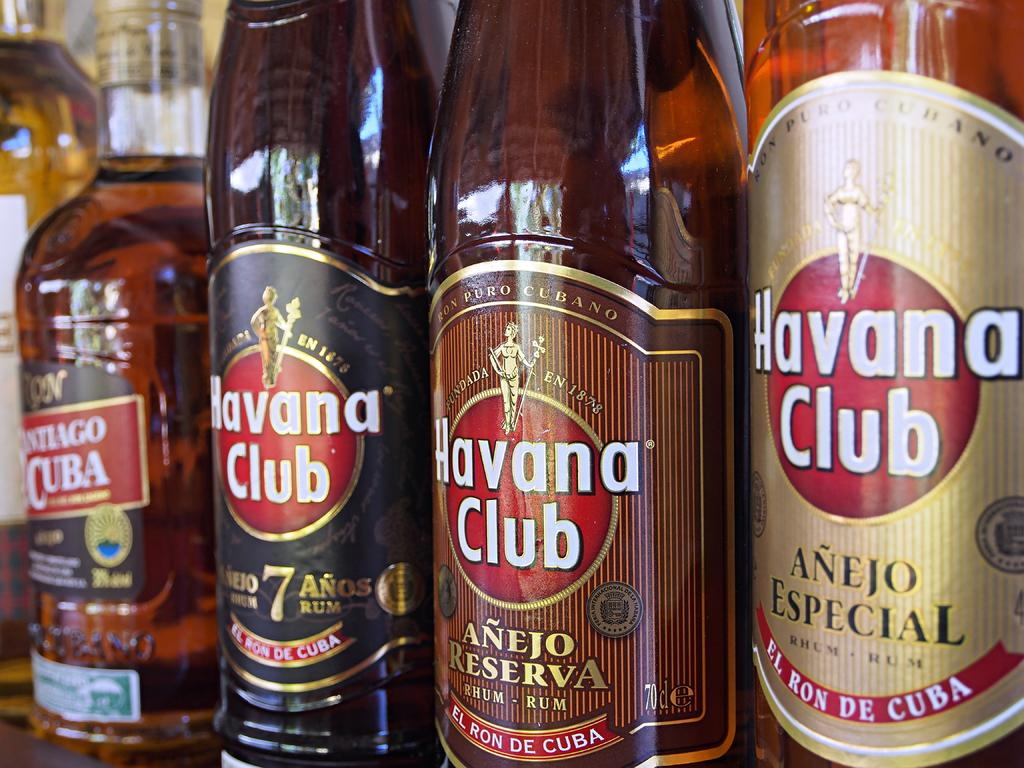Provide a one-sentence caption for the provided image. Several bottles of Havana Club sit in a row on a shelf. 